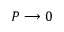<formula> <loc_0><loc_0><loc_500><loc_500>P \longrightarrow 0</formula> 